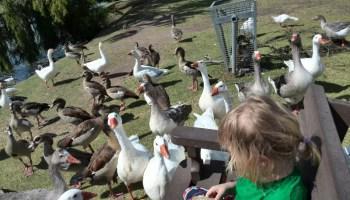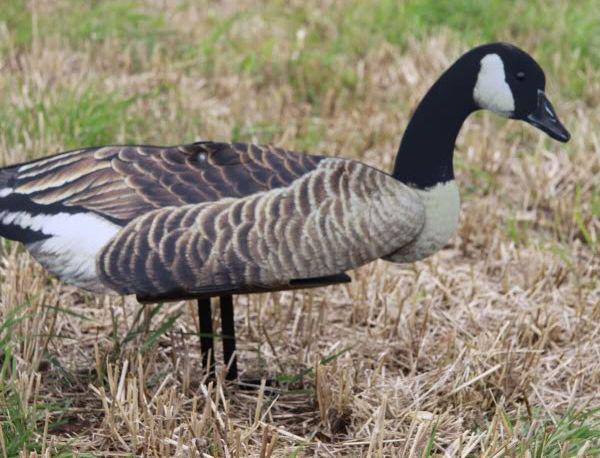The first image is the image on the left, the second image is the image on the right. Given the left and right images, does the statement "Each image shows a flock of canada geese with no fewer than 6 birds" hold true? Answer yes or no. No. The first image is the image on the left, the second image is the image on the right. Examine the images to the left and right. Is the description "There are at least two ducks standing next to each other with orange beaks." accurate? Answer yes or no. Yes. 